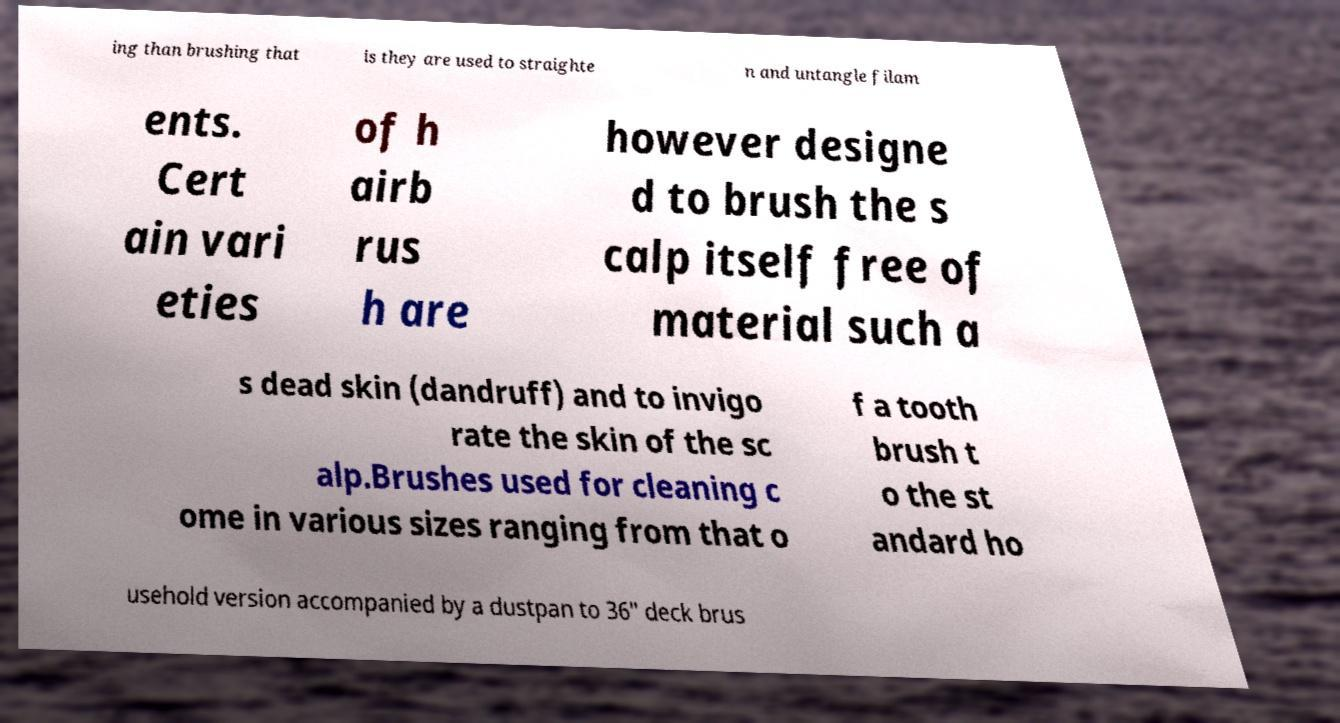There's text embedded in this image that I need extracted. Can you transcribe it verbatim? ing than brushing that is they are used to straighte n and untangle filam ents. Cert ain vari eties of h airb rus h are however designe d to brush the s calp itself free of material such a s dead skin (dandruff) and to invigo rate the skin of the sc alp.Brushes used for cleaning c ome in various sizes ranging from that o f a tooth brush t o the st andard ho usehold version accompanied by a dustpan to 36″ deck brus 